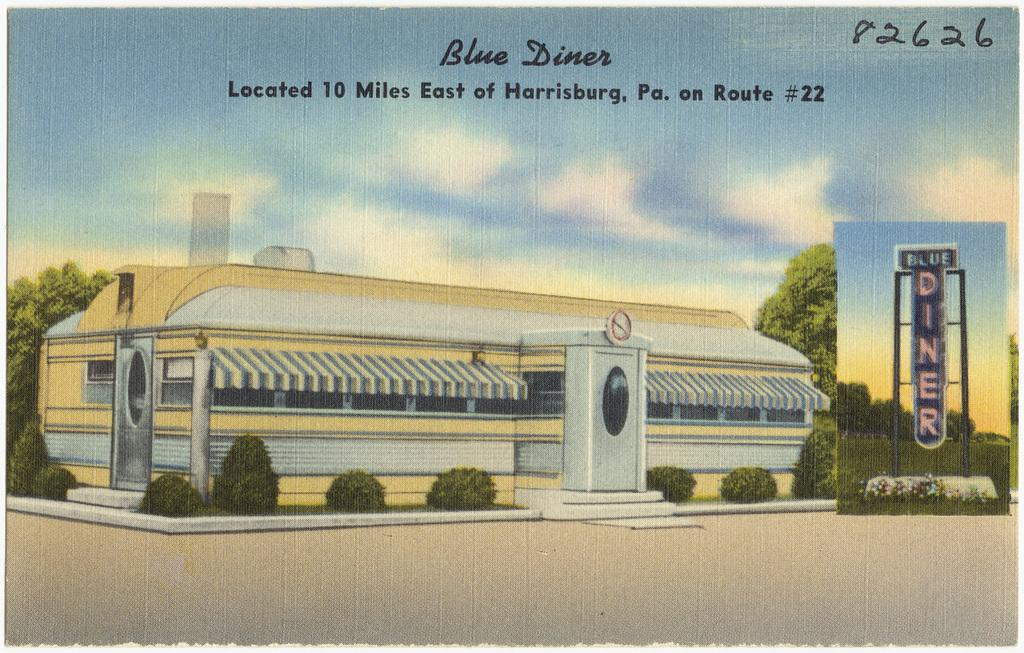Provide a one-sentence caption for the provided image. A painted diner with Blue Diner written above it in the clouds. 